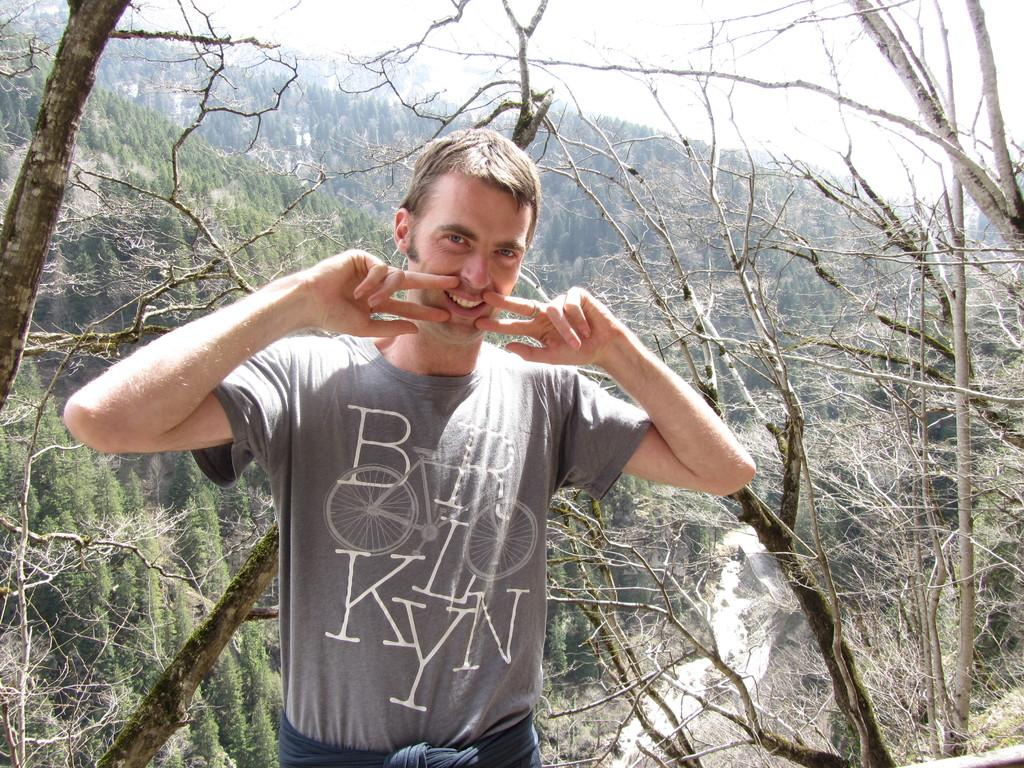What is the main subject of the image? There is a man standing in the image. What can be seen in the background of the image? There is a group of trees visible in the background, and some branches of the trees are also visible. What else is visible in the background of the image? The sky is visible in the background. Can you see the baby's tongue sticking out in the image? There is no baby present in the image. 